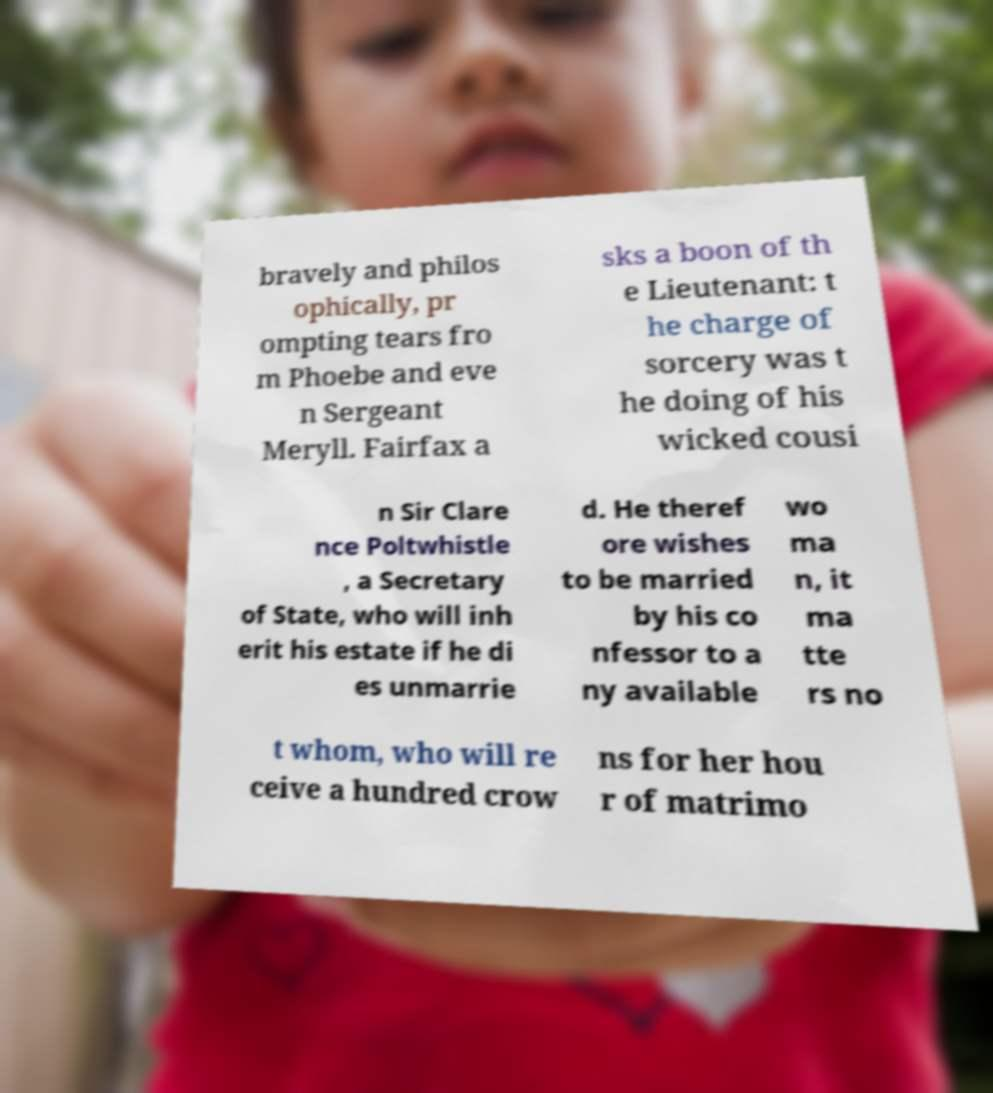Can you accurately transcribe the text from the provided image for me? bravely and philos ophically, pr ompting tears fro m Phoebe and eve n Sergeant Meryll. Fairfax a sks a boon of th e Lieutenant: t he charge of sorcery was t he doing of his wicked cousi n Sir Clare nce Poltwhistle , a Secretary of State, who will inh erit his estate if he di es unmarrie d. He theref ore wishes to be married by his co nfessor to a ny available wo ma n, it ma tte rs no t whom, who will re ceive a hundred crow ns for her hou r of matrimo 